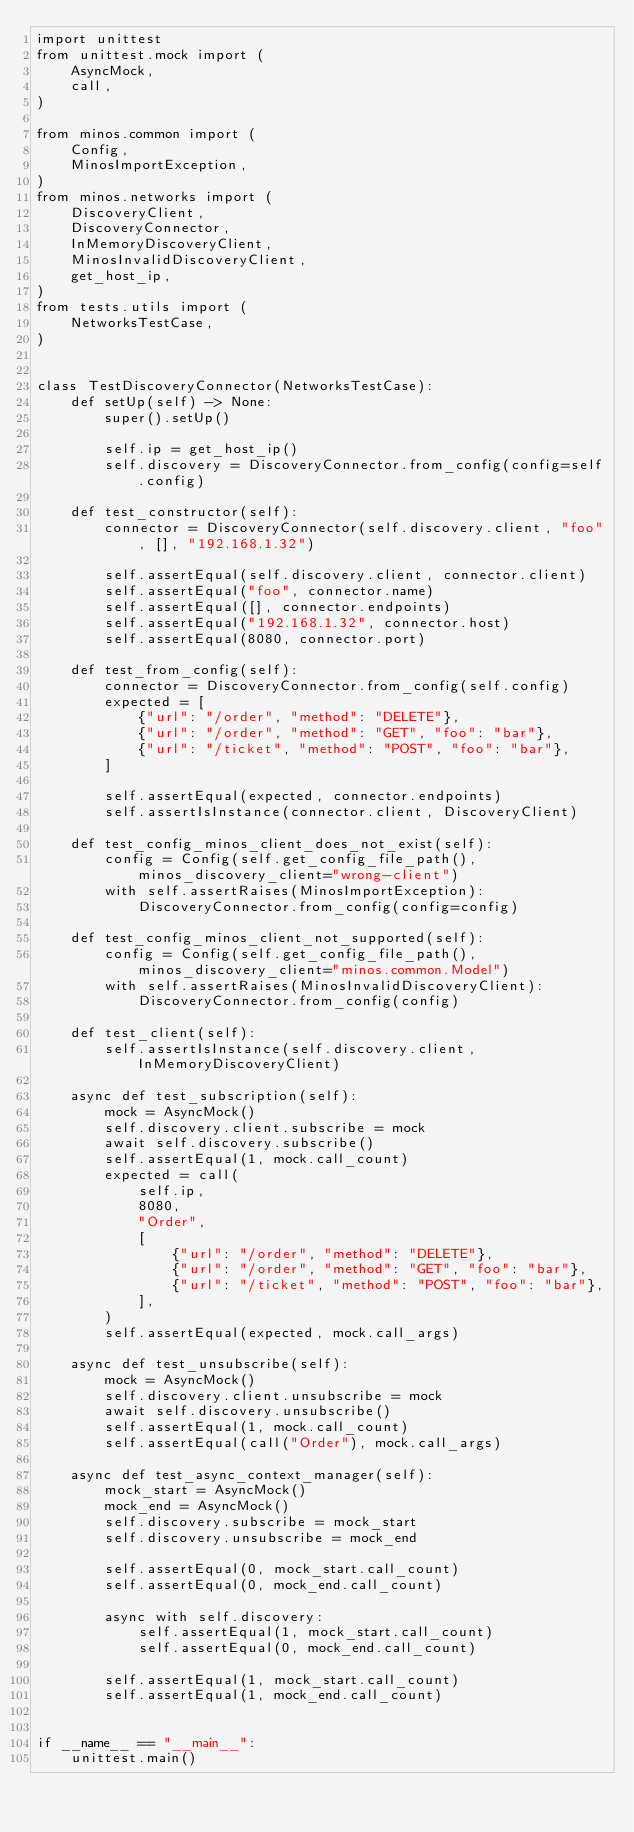<code> <loc_0><loc_0><loc_500><loc_500><_Python_>import unittest
from unittest.mock import (
    AsyncMock,
    call,
)

from minos.common import (
    Config,
    MinosImportException,
)
from minos.networks import (
    DiscoveryClient,
    DiscoveryConnector,
    InMemoryDiscoveryClient,
    MinosInvalidDiscoveryClient,
    get_host_ip,
)
from tests.utils import (
    NetworksTestCase,
)


class TestDiscoveryConnector(NetworksTestCase):
    def setUp(self) -> None:
        super().setUp()

        self.ip = get_host_ip()
        self.discovery = DiscoveryConnector.from_config(config=self.config)

    def test_constructor(self):
        connector = DiscoveryConnector(self.discovery.client, "foo", [], "192.168.1.32")

        self.assertEqual(self.discovery.client, connector.client)
        self.assertEqual("foo", connector.name)
        self.assertEqual([], connector.endpoints)
        self.assertEqual("192.168.1.32", connector.host)
        self.assertEqual(8080, connector.port)

    def test_from_config(self):
        connector = DiscoveryConnector.from_config(self.config)
        expected = [
            {"url": "/order", "method": "DELETE"},
            {"url": "/order", "method": "GET", "foo": "bar"},
            {"url": "/ticket", "method": "POST", "foo": "bar"},
        ]

        self.assertEqual(expected, connector.endpoints)
        self.assertIsInstance(connector.client, DiscoveryClient)

    def test_config_minos_client_does_not_exist(self):
        config = Config(self.get_config_file_path(), minos_discovery_client="wrong-client")
        with self.assertRaises(MinosImportException):
            DiscoveryConnector.from_config(config=config)

    def test_config_minos_client_not_supported(self):
        config = Config(self.get_config_file_path(), minos_discovery_client="minos.common.Model")
        with self.assertRaises(MinosInvalidDiscoveryClient):
            DiscoveryConnector.from_config(config)

    def test_client(self):
        self.assertIsInstance(self.discovery.client, InMemoryDiscoveryClient)

    async def test_subscription(self):
        mock = AsyncMock()
        self.discovery.client.subscribe = mock
        await self.discovery.subscribe()
        self.assertEqual(1, mock.call_count)
        expected = call(
            self.ip,
            8080,
            "Order",
            [
                {"url": "/order", "method": "DELETE"},
                {"url": "/order", "method": "GET", "foo": "bar"},
                {"url": "/ticket", "method": "POST", "foo": "bar"},
            ],
        )
        self.assertEqual(expected, mock.call_args)

    async def test_unsubscribe(self):
        mock = AsyncMock()
        self.discovery.client.unsubscribe = mock
        await self.discovery.unsubscribe()
        self.assertEqual(1, mock.call_count)
        self.assertEqual(call("Order"), mock.call_args)

    async def test_async_context_manager(self):
        mock_start = AsyncMock()
        mock_end = AsyncMock()
        self.discovery.subscribe = mock_start
        self.discovery.unsubscribe = mock_end

        self.assertEqual(0, mock_start.call_count)
        self.assertEqual(0, mock_end.call_count)

        async with self.discovery:
            self.assertEqual(1, mock_start.call_count)
            self.assertEqual(0, mock_end.call_count)

        self.assertEqual(1, mock_start.call_count)
        self.assertEqual(1, mock_end.call_count)


if __name__ == "__main__":
    unittest.main()
</code> 